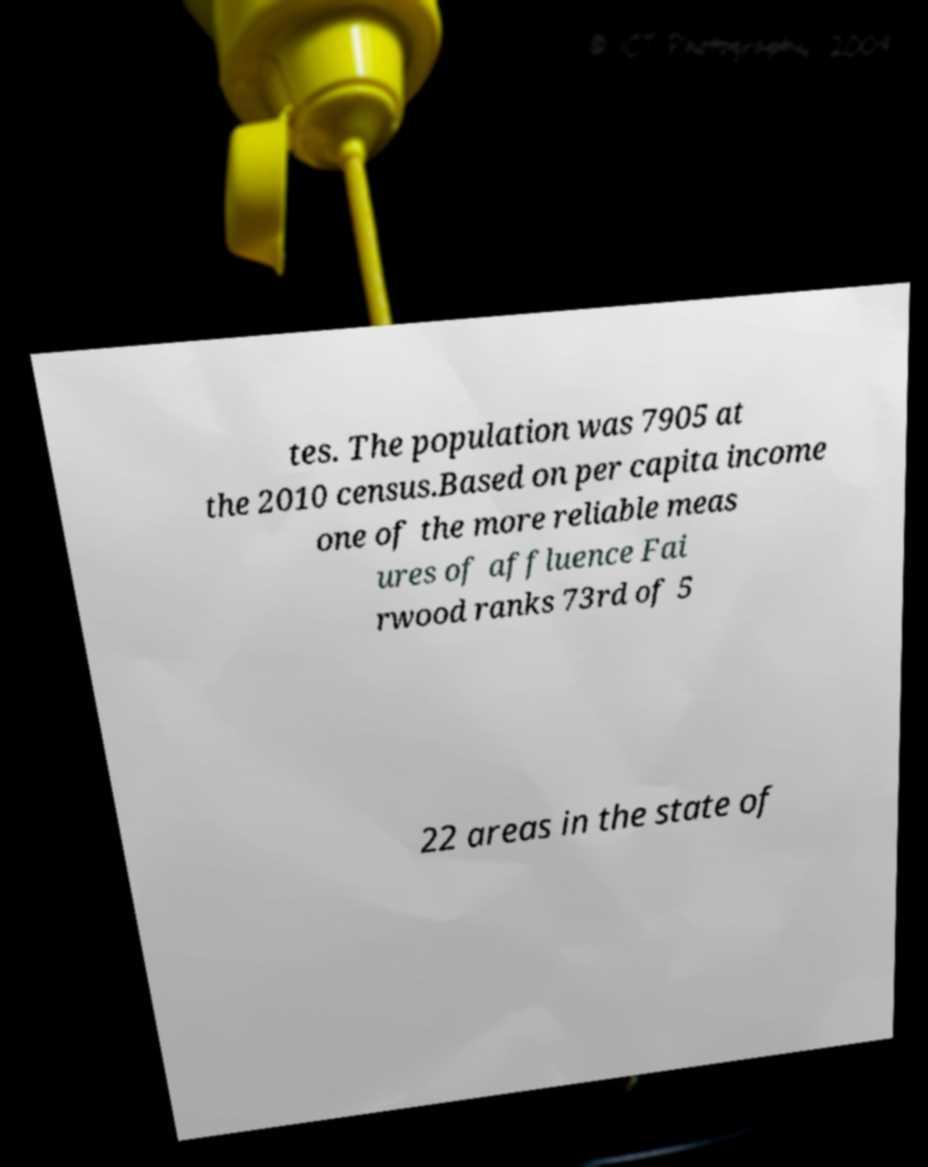Can you accurately transcribe the text from the provided image for me? tes. The population was 7905 at the 2010 census.Based on per capita income one of the more reliable meas ures of affluence Fai rwood ranks 73rd of 5 22 areas in the state of 